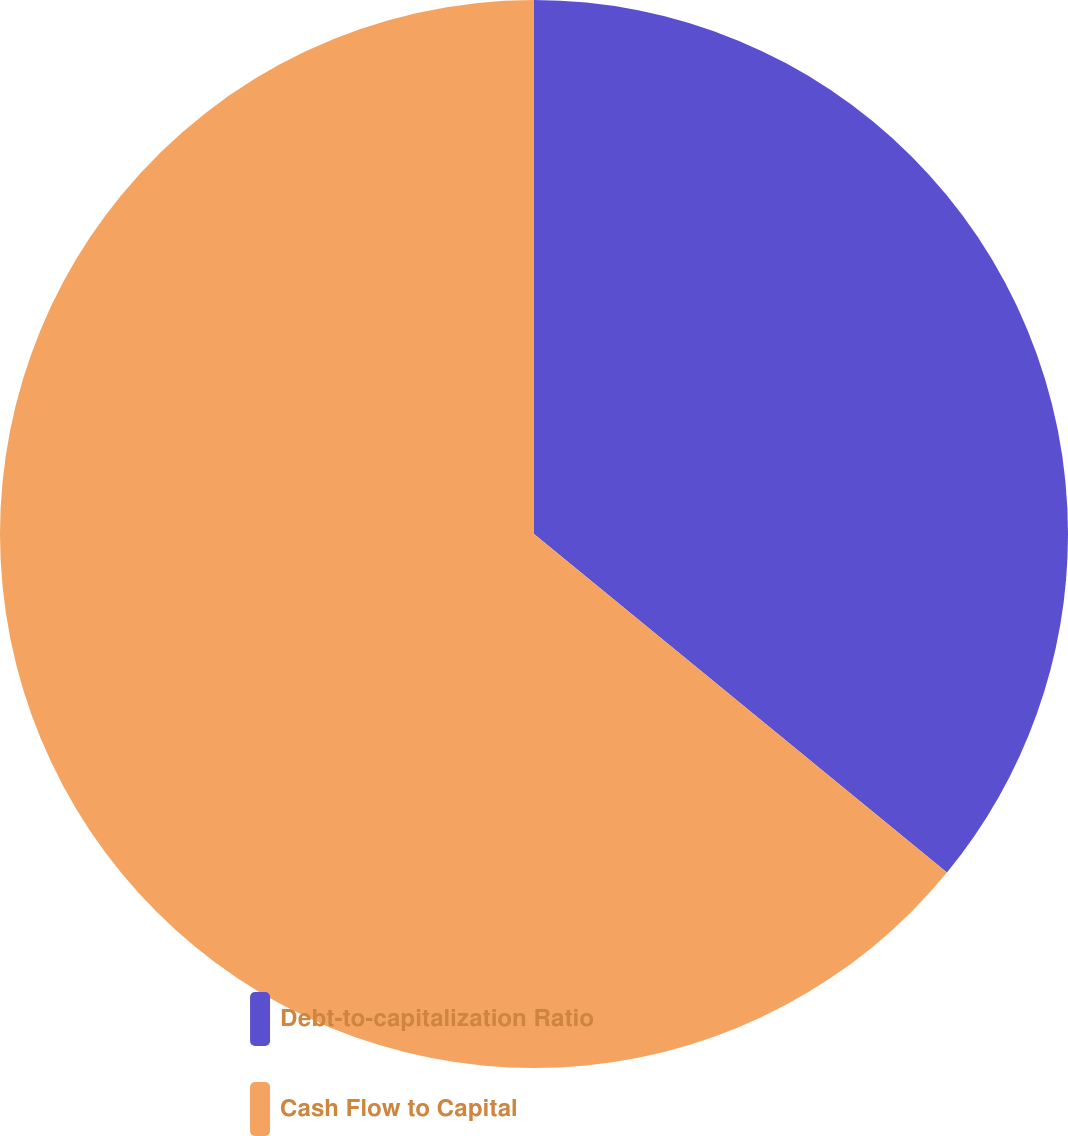Convert chart to OTSL. <chart><loc_0><loc_0><loc_500><loc_500><pie_chart><fcel>Debt-to-capitalization Ratio<fcel>Cash Flow to Capital<nl><fcel>35.93%<fcel>64.07%<nl></chart> 